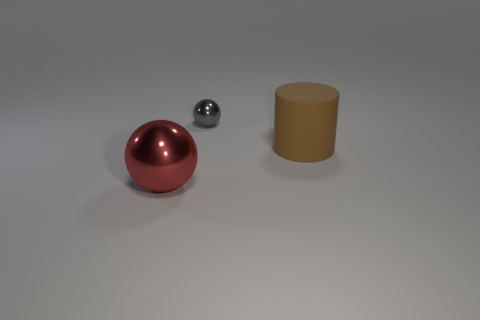Add 1 balls. How many objects exist? 4 Subtract all cylinders. How many objects are left? 2 Subtract all yellow shiny cylinders. Subtract all small shiny spheres. How many objects are left? 2 Add 1 gray balls. How many gray balls are left? 2 Add 2 tiny purple metal balls. How many tiny purple metal balls exist? 2 Subtract 0 red cubes. How many objects are left? 3 Subtract all gray spheres. Subtract all gray blocks. How many spheres are left? 1 